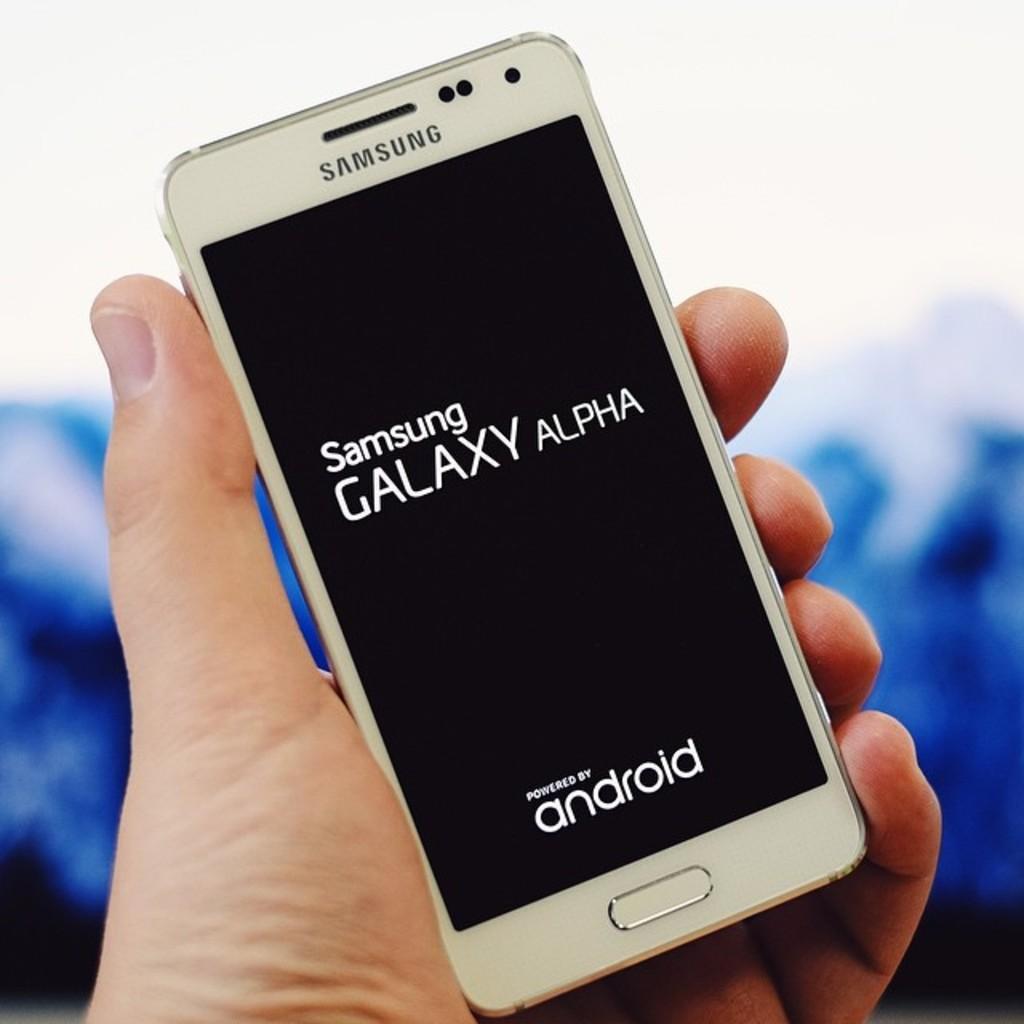Can you describe this image briefly? In the center of the image we can see mobile phone in person's hand. 